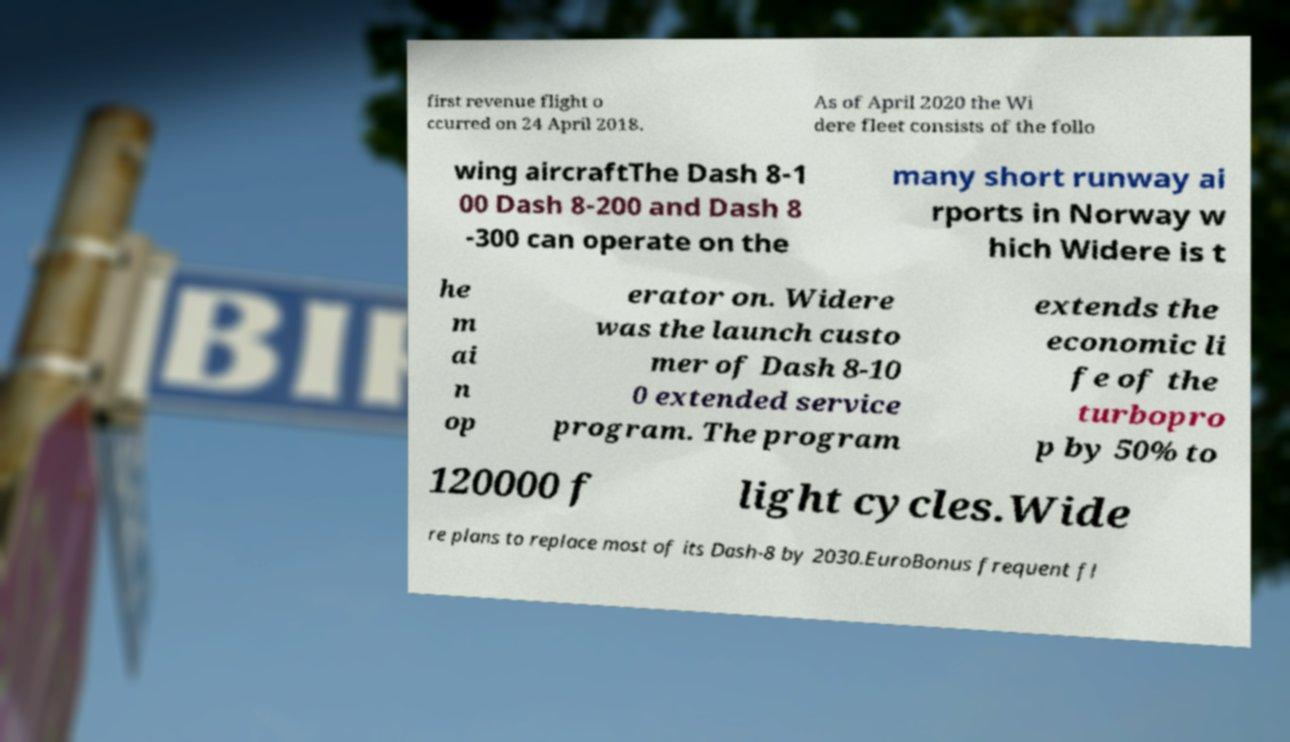Can you read and provide the text displayed in the image?This photo seems to have some interesting text. Can you extract and type it out for me? first revenue flight o ccurred on 24 April 2018. As of April 2020 the Wi dere fleet consists of the follo wing aircraftThe Dash 8-1 00 Dash 8-200 and Dash 8 -300 can operate on the many short runway ai rports in Norway w hich Widere is t he m ai n op erator on. Widere was the launch custo mer of Dash 8-10 0 extended service program. The program extends the economic li fe of the turbopro p by 50% to 120000 f light cycles.Wide re plans to replace most of its Dash-8 by 2030.EuroBonus frequent fl 